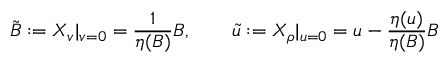<formula> <loc_0><loc_0><loc_500><loc_500>{ \tilde { B } } \colon = X _ { v } | _ { v = 0 } = \frac { 1 } { \eta ( B ) } B , \quad \tilde { u } \colon = X _ { \rho } | _ { u = 0 } = u - \frac { \eta ( u ) } { \eta ( B ) } B</formula> 